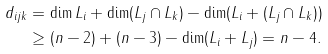Convert formula to latex. <formula><loc_0><loc_0><loc_500><loc_500>d _ { i j k } & = \dim L _ { i } + \dim ( L _ { j } \cap L _ { k } ) - \dim ( L _ { i } + ( L _ { j } \cap L _ { k } ) ) \\ & \geq ( n - 2 ) + ( n - 3 ) - \dim ( L _ { i } + L _ { j } ) = n - 4 .</formula> 